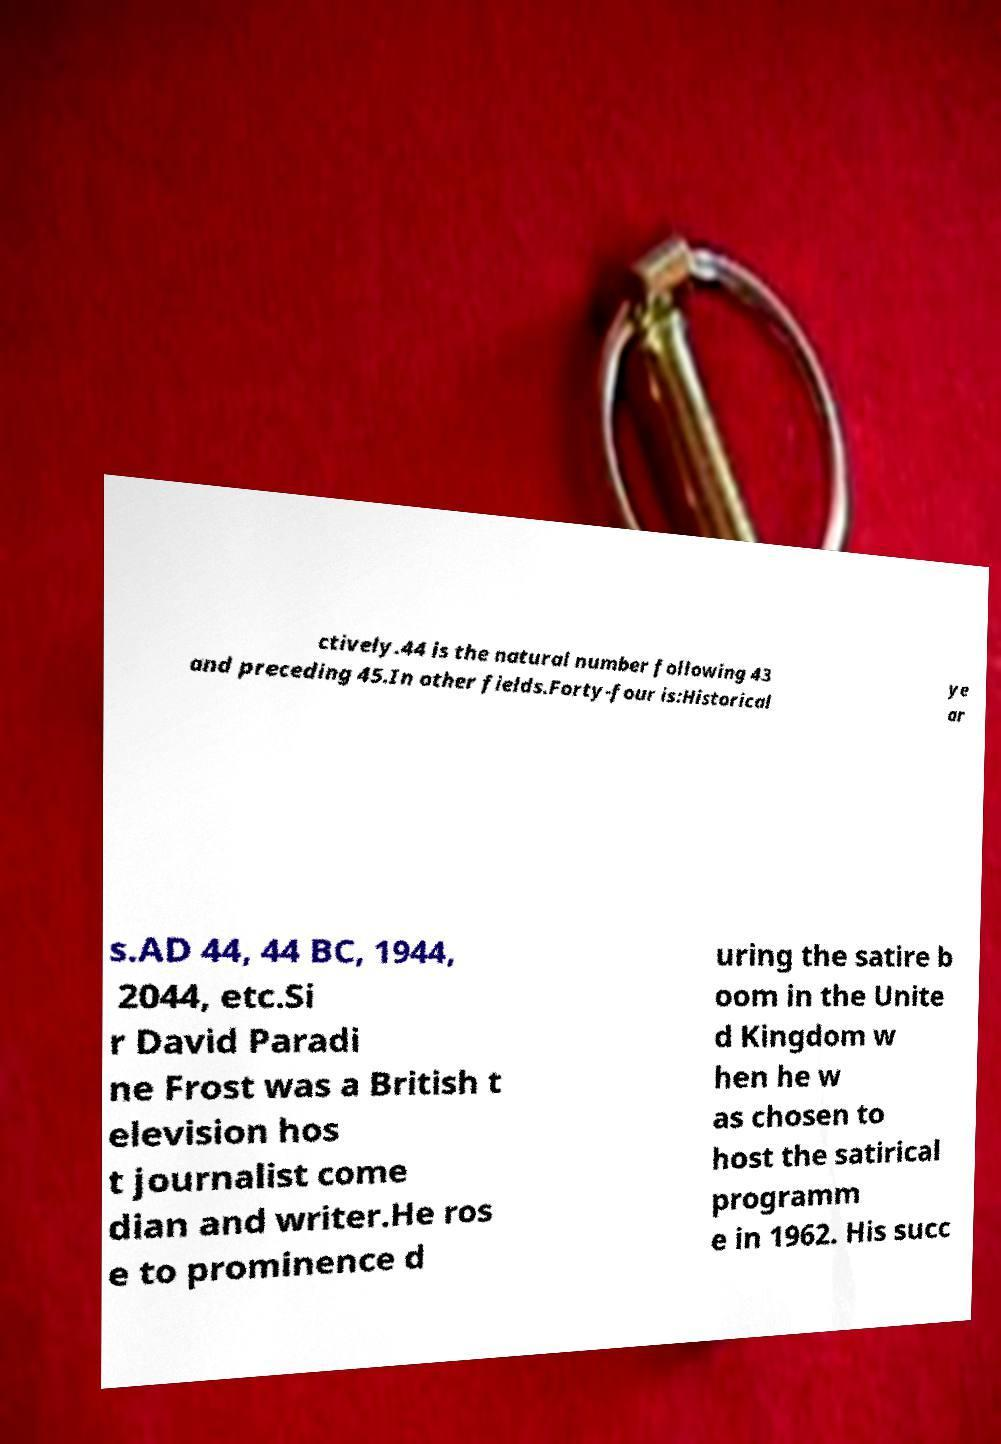Can you accurately transcribe the text from the provided image for me? ctively.44 is the natural number following 43 and preceding 45.In other fields.Forty-four is:Historical ye ar s.AD 44, 44 BC, 1944, 2044, etc.Si r David Paradi ne Frost was a British t elevision hos t journalist come dian and writer.He ros e to prominence d uring the satire b oom in the Unite d Kingdom w hen he w as chosen to host the satirical programm e in 1962. His succ 